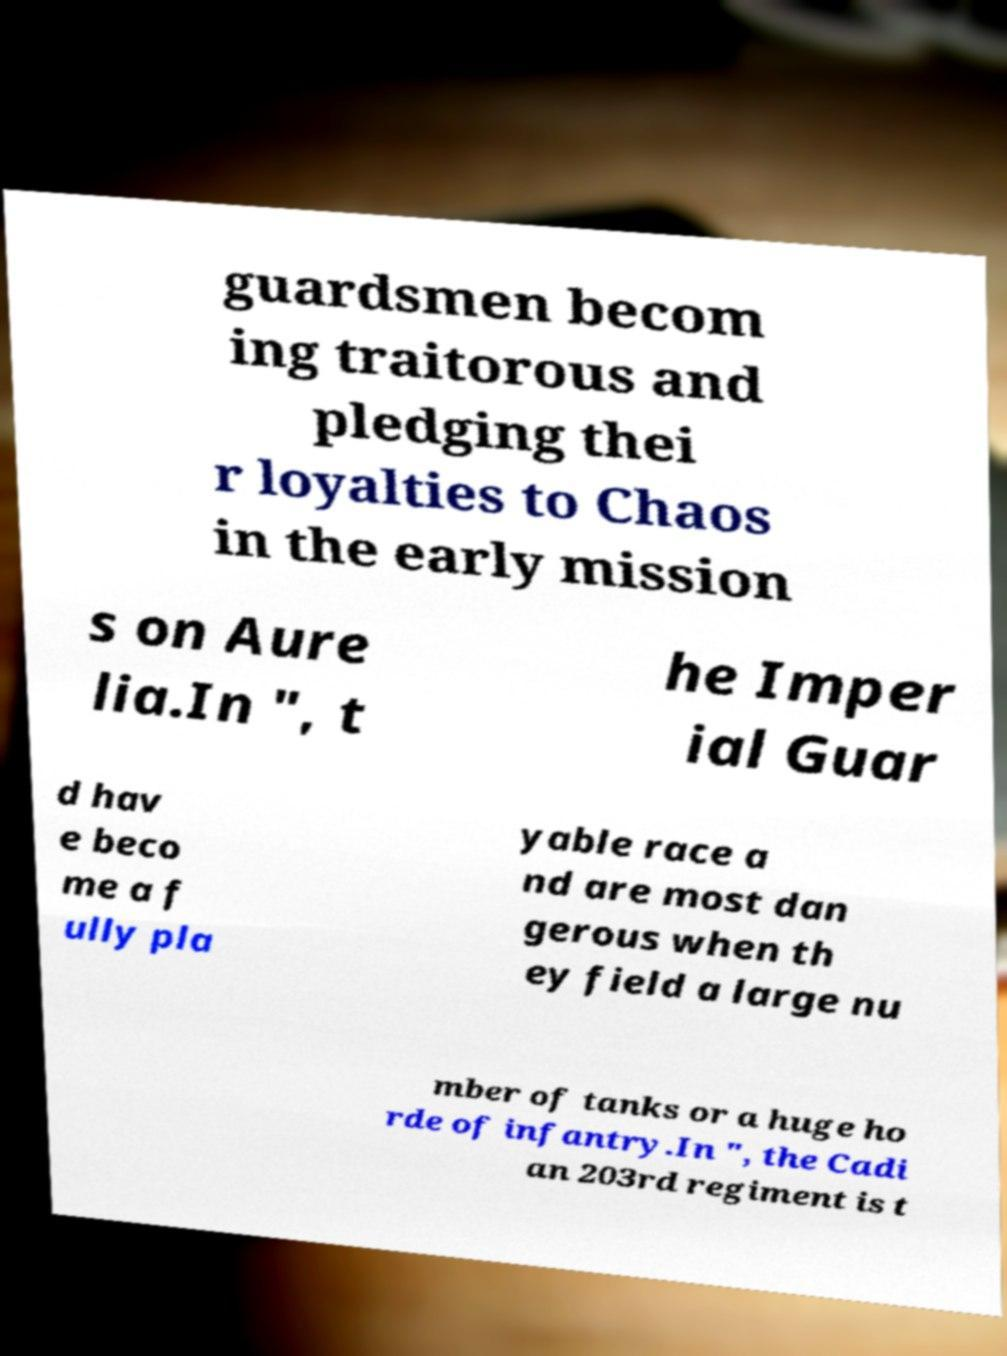What messages or text are displayed in this image? I need them in a readable, typed format. guardsmen becom ing traitorous and pledging thei r loyalties to Chaos in the early mission s on Aure lia.In ", t he Imper ial Guar d hav e beco me a f ully pla yable race a nd are most dan gerous when th ey field a large nu mber of tanks or a huge ho rde of infantry.In ", the Cadi an 203rd regiment is t 